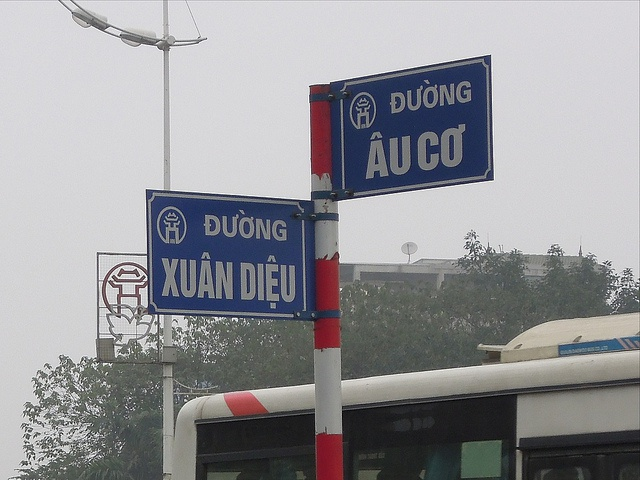Describe the objects in this image and their specific colors. I can see bus in lightgray, black, darkgray, and gray tones in this image. 